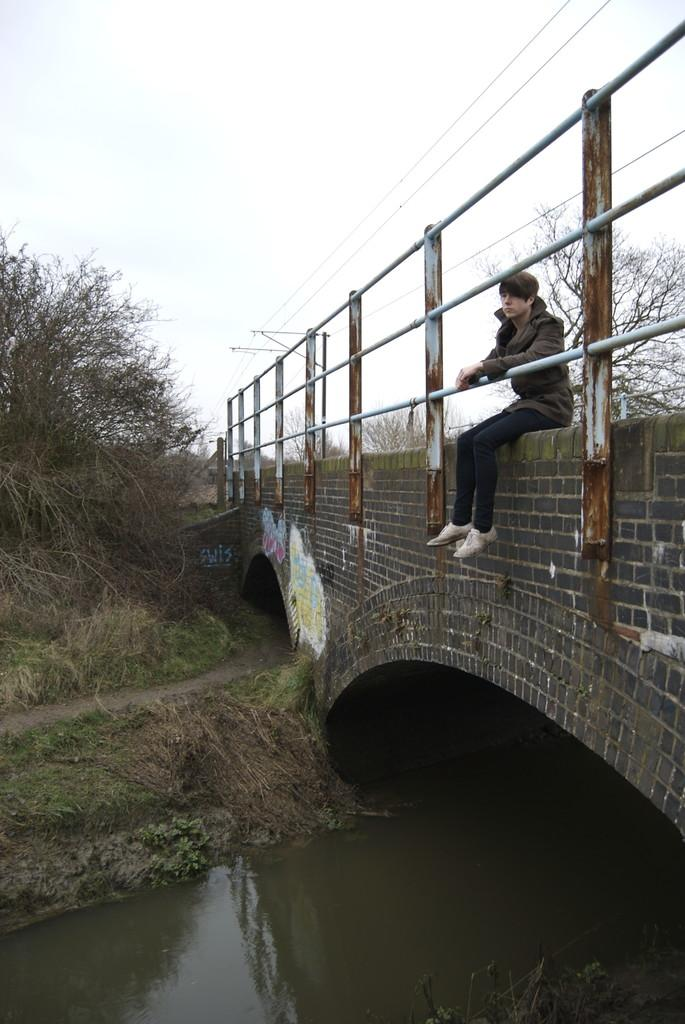What type of structure can be seen in the image? There is a bridge with railing in the image. Can you describe the person in the image? There is a person sitting in the image. What type of vegetation is visible in the image? Trees are visible in the image. What type of ground surface is present in the image? Grass is present in the image. What natural element can be seen in the image? There is water visible in the image. What part of the natural environment is visible in the image? The sky is visible in the image. How much tax is being paid by the person sitting on the bridge in the image? There is no information about taxes in the image, as it focuses on the bridge, person, vegetation, ground surface, water, and sky. 